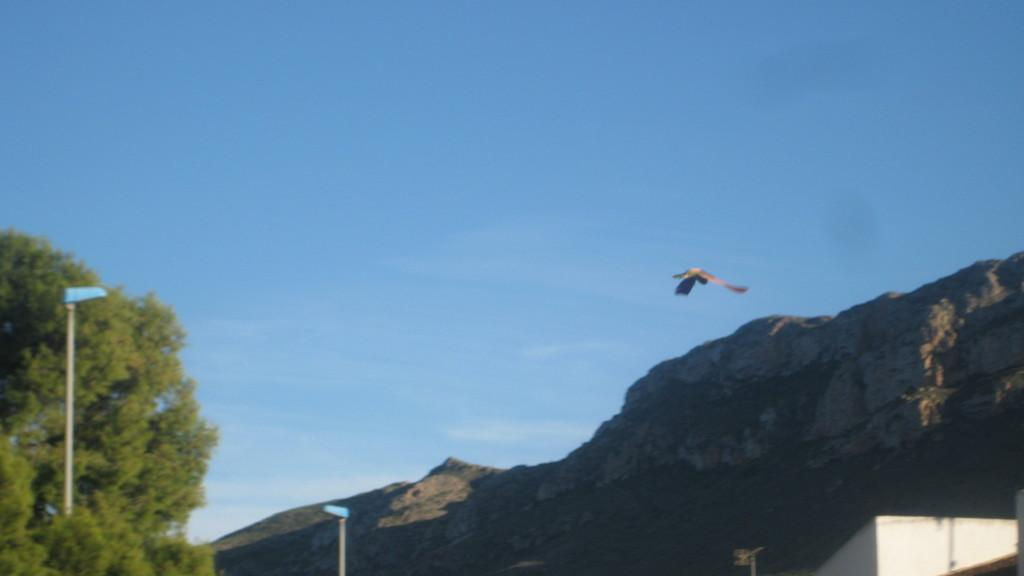What type of vegetation can be seen in the image? There are trees in the image. What objects are present in the image that provide illumination? There are lights in the image. What structures can be seen in the image that support the lights? There are poles in the image. What geographical feature is visible in the image? There is a hill in the image. What type of animal can be seen in the sky in the image? A bird is flying in the sky in the image. Where is the house located in the image? There is no house present in the image. What type of field can be seen in the image? There is no field present in the image. 